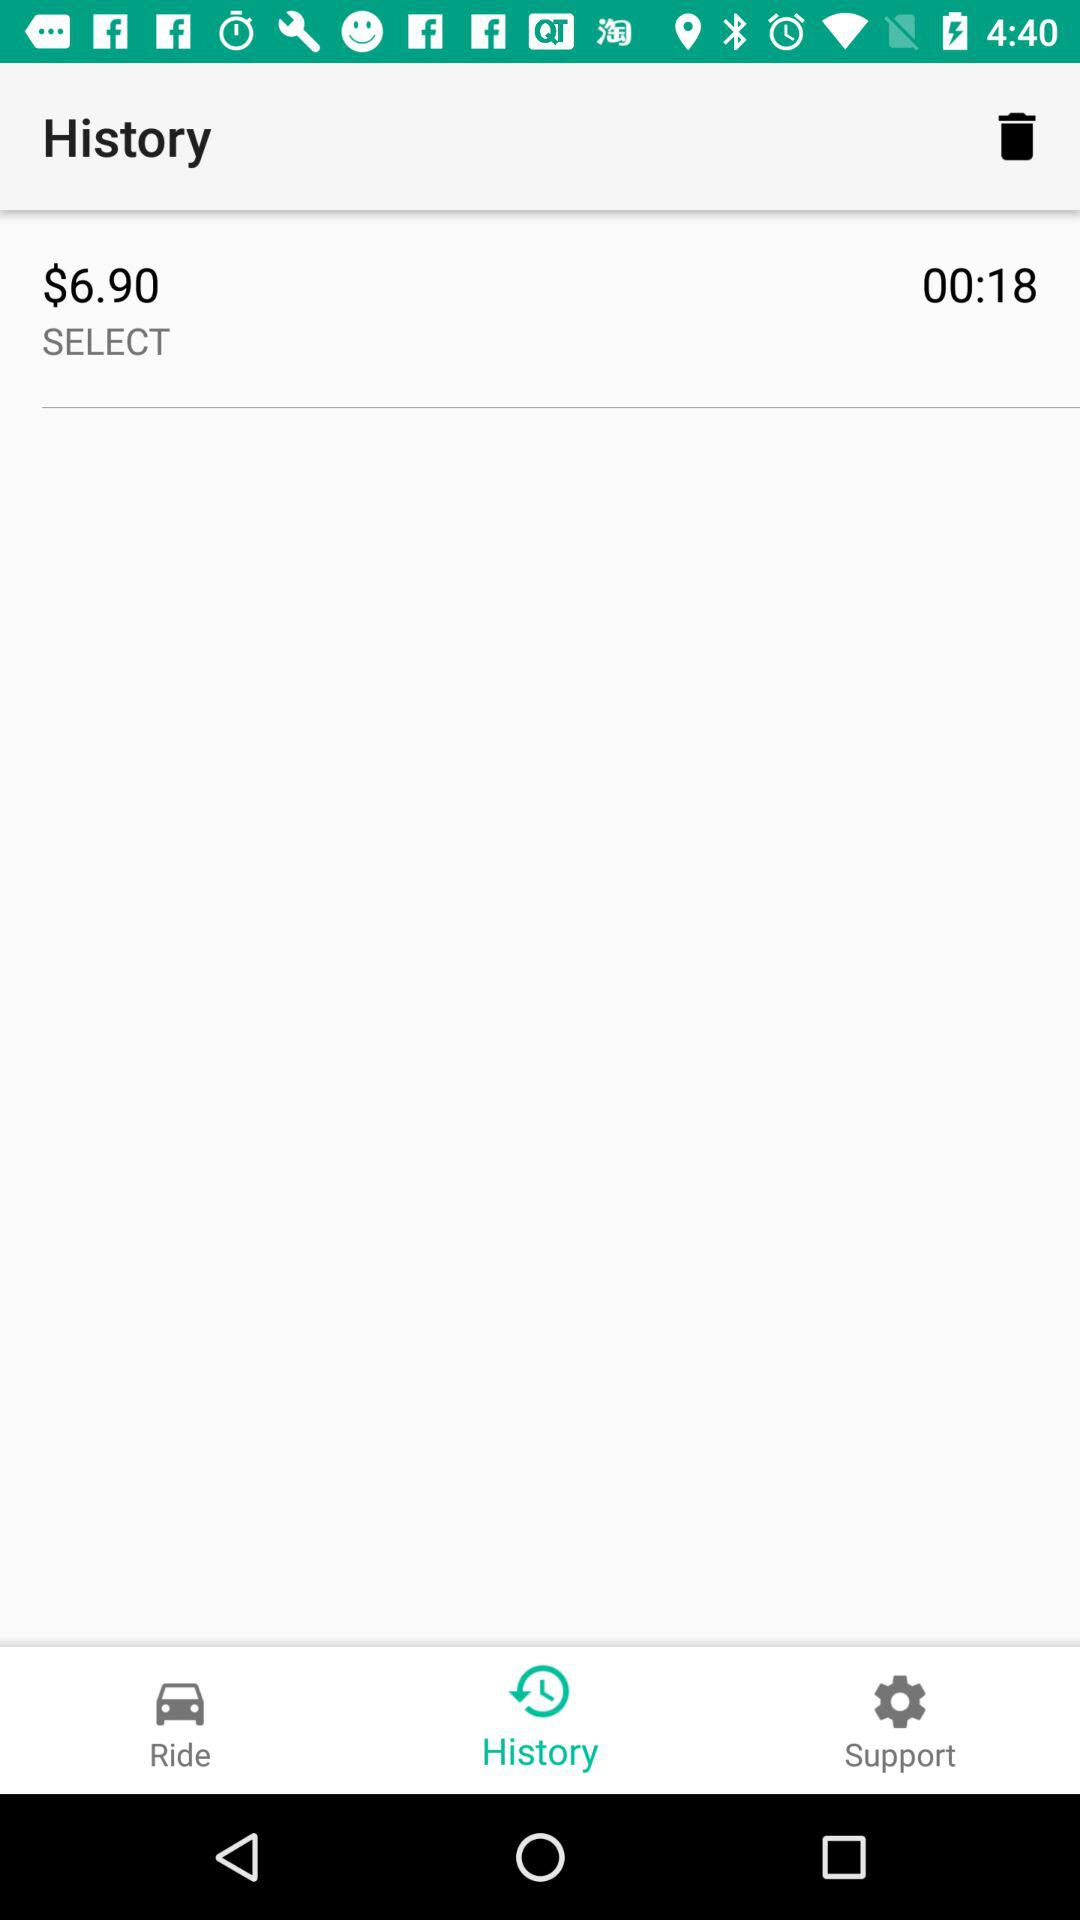What is the currency of price? The currency is "Dollar". 